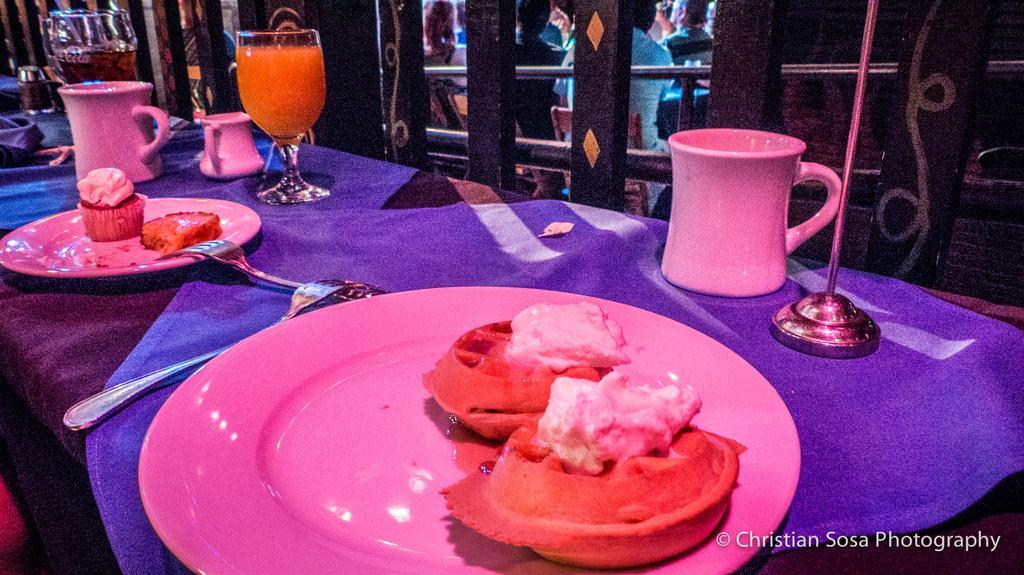Could you give a brief overview of what you see in this image? In this image I see tables on which there are glasses, cups and plates on which there is food and I see the forks. In the background I see few people who are sitting on chairs. 